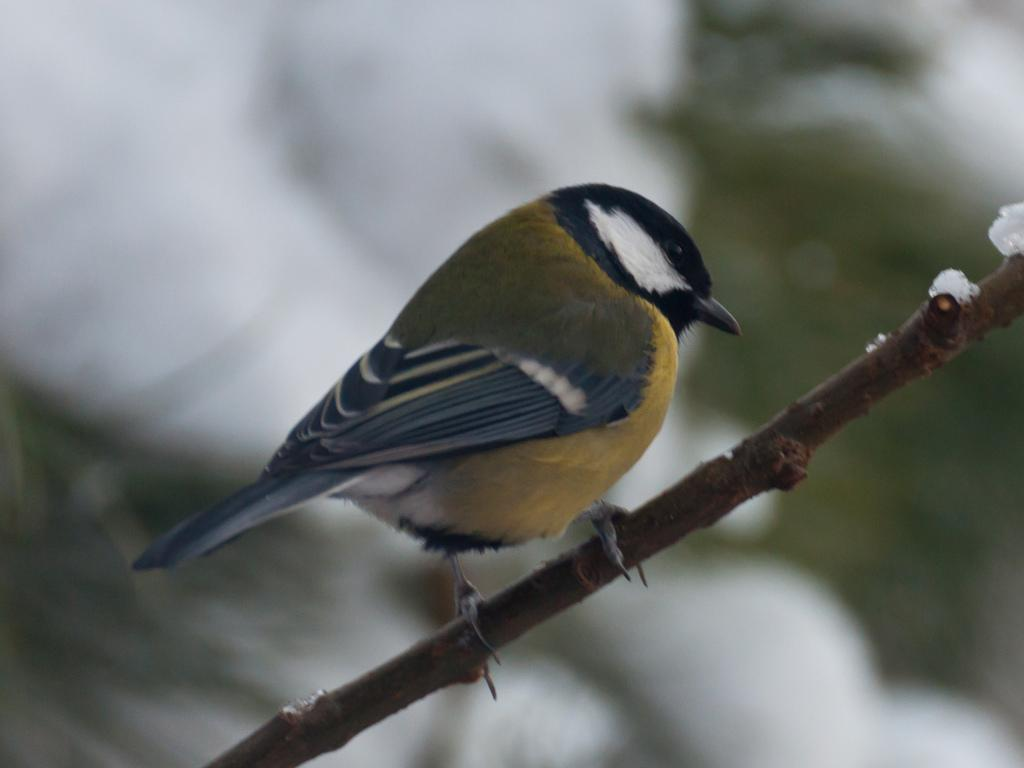What type of animal is in the image? There is a bird in the image. How is the bird positioned in the image? The bird is on a stick. What is the texture or state of the substance visible in the image? There is ice visible in the image. Can you describe the background of the image? The background of the image is blurry. How many rabbits are serving food in the image? There are no rabbits or food present in the image. What type of servant is attending to the bird in the image? There is no servant present in the image; the bird is on a stick. 